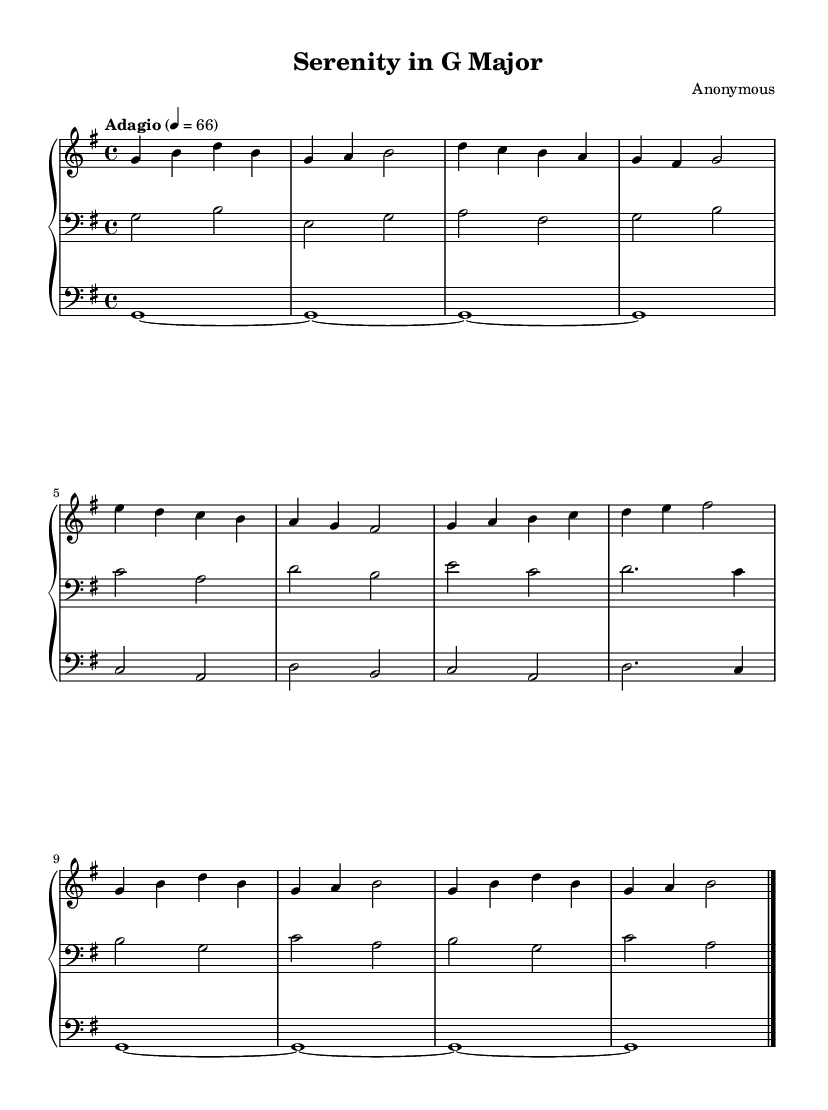What is the key signature of this music? The key signature is identified by the two sharps in the key signature area at the beginning of the staff. This indicates that the piece is in G major.
Answer: G major What is the time signature of this music? The time signature is located at the beginning of the music and is indicated as 4/4, which represents four beats per measure.
Answer: 4/4 What is the tempo marking found in this composition? The tempo marking is indicated with "Adagio," suggesting a slow pace for the music, and the metronome marking specifies a tempo of 66 beats per minute.
Answer: Adagio How many measures are in the right hand? By counting the individual measures indicated in the right-hand staff, I can see that there are a total of 8 measures in the right hand.
Answer: 8 What is the last note in the left hand? By examining the last measure of the left-hand staff, the last note is D, as indicated in the final measure shown in that staff.
Answer: D What type of harmony is predominantly used in this piece? The harmony can be analyzed by looking at the intervals and chords throughout the composition, showing that triadic harmony is primarily employed in this work, typical of Baroque style.
Answer: Triadic harmony What is the overall mood conveyed by the composition? The composition's structure, melody, and tempo together convey a calming and reflective mood, which is characteristic of pieces designed for meditation and contemplation in the Baroque style.
Answer: Calming 